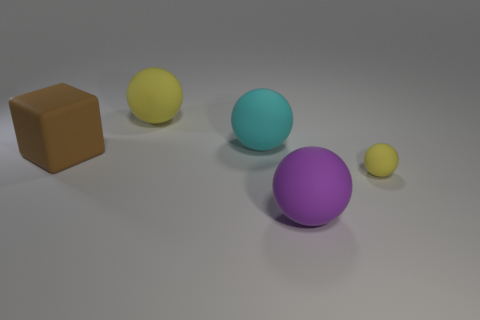Subtract 1 spheres. How many spheres are left? 3 Add 3 rubber spheres. How many objects exist? 8 Subtract all blocks. How many objects are left? 4 Subtract 0 blue cylinders. How many objects are left? 5 Subtract all cyan spheres. Subtract all cyan shiny cylinders. How many objects are left? 4 Add 2 small yellow balls. How many small yellow balls are left? 3 Add 5 small purple cubes. How many small purple cubes exist? 5 